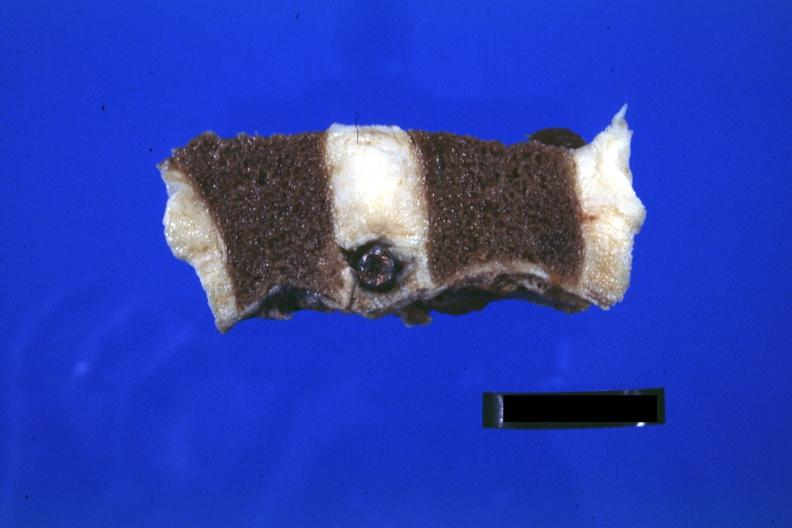what does this image show?
Answer the question using a single word or phrase. Close-up view well shown 